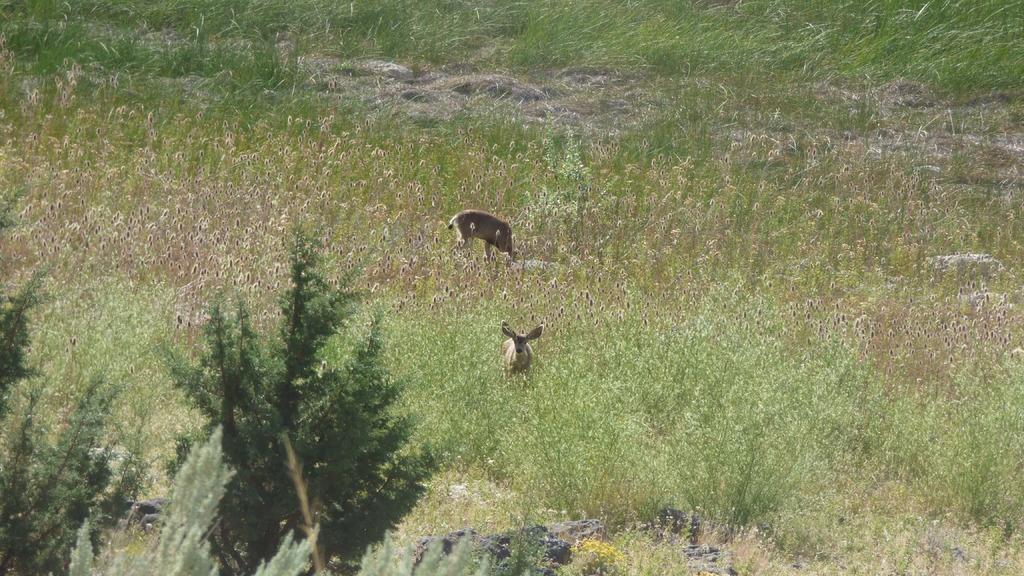Describe this image in one or two sentences. In the image there is a lot of grass and in between the grass there are two animals, there are trees in the foreground. 